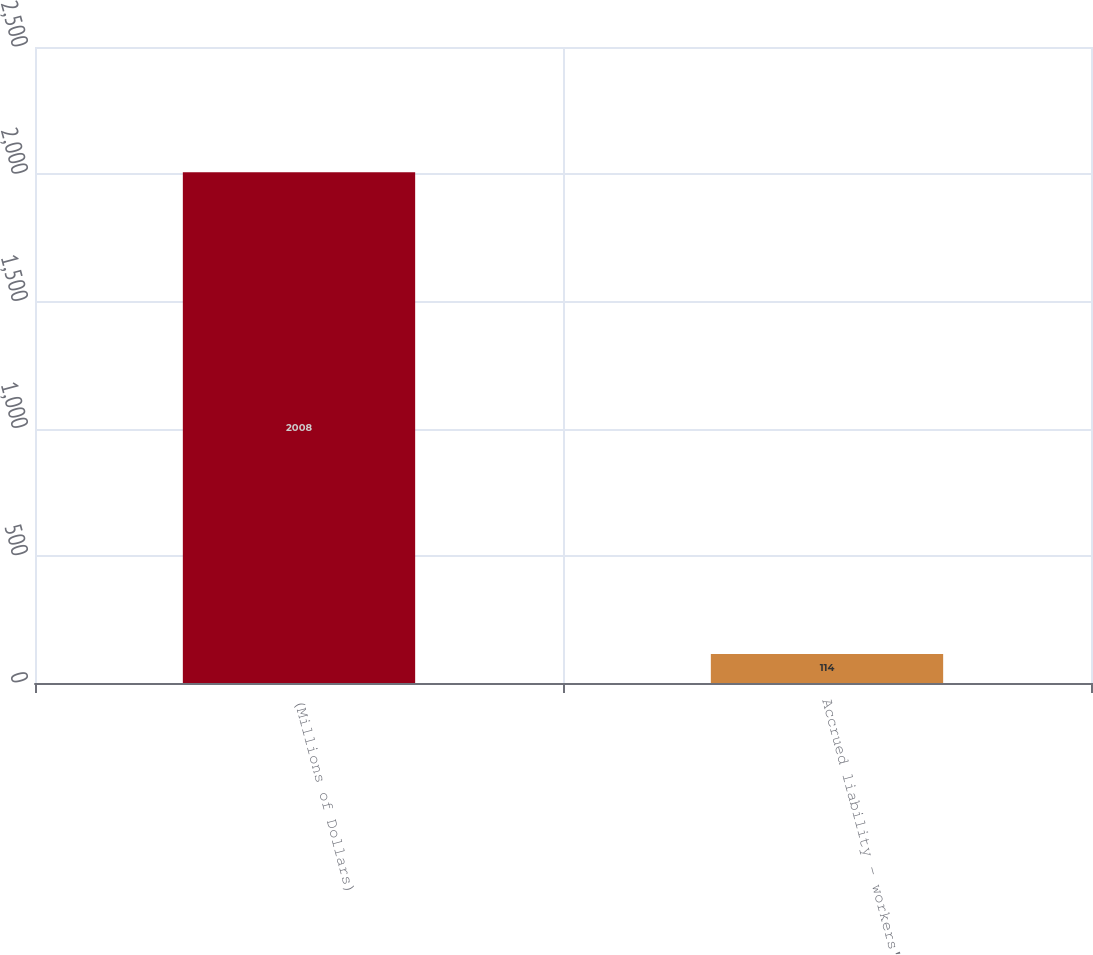Convert chart. <chart><loc_0><loc_0><loc_500><loc_500><bar_chart><fcel>(Millions of Dollars)<fcel>Accrued liability - workers'<nl><fcel>2008<fcel>114<nl></chart> 